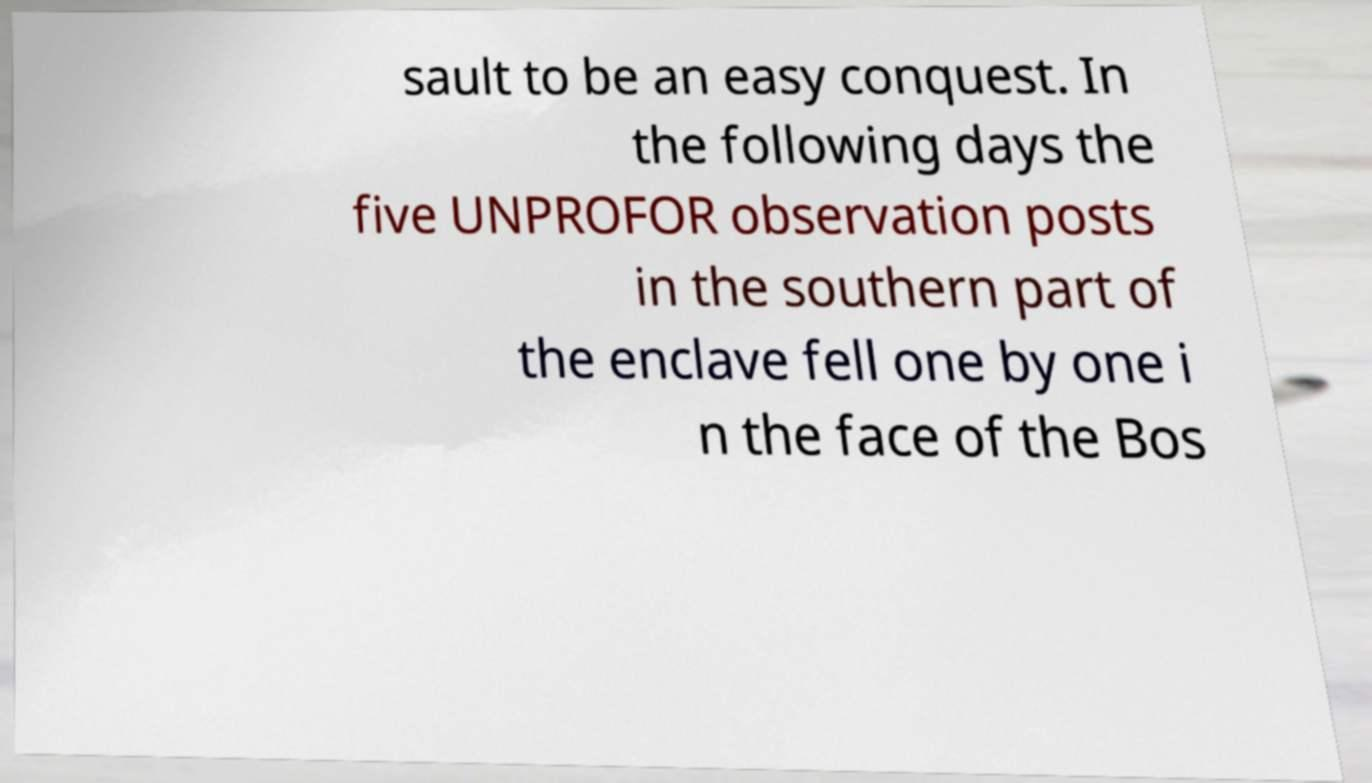Could you assist in decoding the text presented in this image and type it out clearly? sault to be an easy conquest. In the following days the five UNPROFOR observation posts in the southern part of the enclave fell one by one i n the face of the Bos 